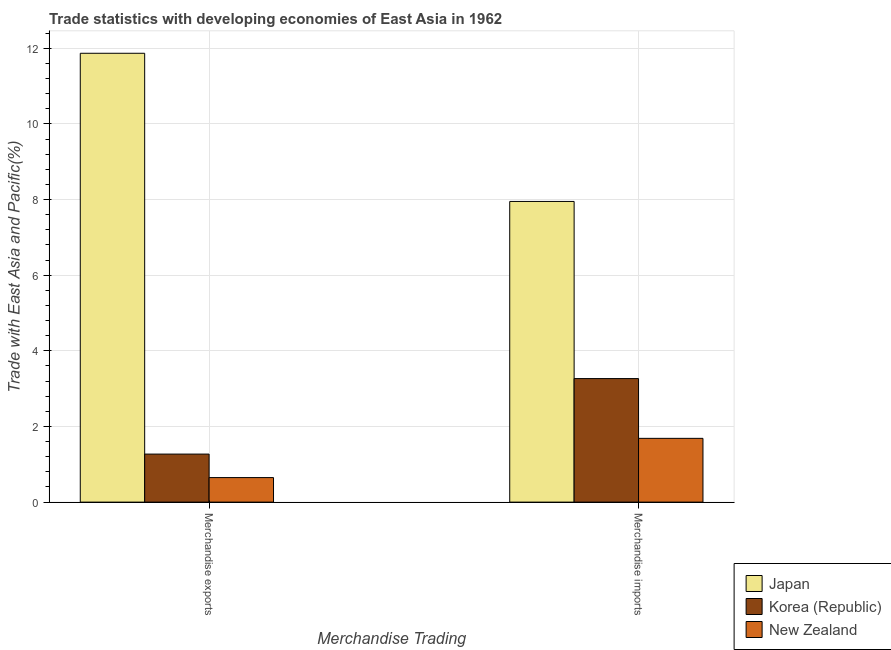How many groups of bars are there?
Provide a succinct answer. 2. Are the number of bars on each tick of the X-axis equal?
Keep it short and to the point. Yes. How many bars are there on the 2nd tick from the left?
Make the answer very short. 3. How many bars are there on the 1st tick from the right?
Give a very brief answer. 3. What is the label of the 2nd group of bars from the left?
Ensure brevity in your answer.  Merchandise imports. What is the merchandise imports in New Zealand?
Make the answer very short. 1.69. Across all countries, what is the maximum merchandise imports?
Your response must be concise. 7.95. Across all countries, what is the minimum merchandise imports?
Give a very brief answer. 1.69. In which country was the merchandise imports maximum?
Provide a succinct answer. Japan. In which country was the merchandise exports minimum?
Offer a terse response. New Zealand. What is the total merchandise exports in the graph?
Give a very brief answer. 13.79. What is the difference between the merchandise exports in Japan and that in New Zealand?
Offer a very short reply. 11.22. What is the difference between the merchandise imports in Korea (Republic) and the merchandise exports in Japan?
Offer a terse response. -8.6. What is the average merchandise imports per country?
Your answer should be very brief. 4.3. What is the difference between the merchandise exports and merchandise imports in Japan?
Your answer should be very brief. 3.92. In how many countries, is the merchandise exports greater than 10 %?
Provide a short and direct response. 1. What is the ratio of the merchandise imports in Korea (Republic) to that in Japan?
Offer a very short reply. 0.41. Is the merchandise imports in New Zealand less than that in Japan?
Keep it short and to the point. Yes. In how many countries, is the merchandise exports greater than the average merchandise exports taken over all countries?
Offer a terse response. 1. Are all the bars in the graph horizontal?
Your response must be concise. No. How many countries are there in the graph?
Keep it short and to the point. 3. Does the graph contain grids?
Give a very brief answer. Yes. How many legend labels are there?
Provide a short and direct response. 3. How are the legend labels stacked?
Provide a succinct answer. Vertical. What is the title of the graph?
Your answer should be compact. Trade statistics with developing economies of East Asia in 1962. Does "Sri Lanka" appear as one of the legend labels in the graph?
Keep it short and to the point. No. What is the label or title of the X-axis?
Offer a very short reply. Merchandise Trading. What is the label or title of the Y-axis?
Keep it short and to the point. Trade with East Asia and Pacific(%). What is the Trade with East Asia and Pacific(%) of Japan in Merchandise exports?
Your response must be concise. 11.87. What is the Trade with East Asia and Pacific(%) of Korea (Republic) in Merchandise exports?
Your answer should be compact. 1.27. What is the Trade with East Asia and Pacific(%) of New Zealand in Merchandise exports?
Your answer should be compact. 0.65. What is the Trade with East Asia and Pacific(%) of Japan in Merchandise imports?
Your response must be concise. 7.95. What is the Trade with East Asia and Pacific(%) in Korea (Republic) in Merchandise imports?
Offer a terse response. 3.27. What is the Trade with East Asia and Pacific(%) in New Zealand in Merchandise imports?
Offer a terse response. 1.69. Across all Merchandise Trading, what is the maximum Trade with East Asia and Pacific(%) of Japan?
Ensure brevity in your answer.  11.87. Across all Merchandise Trading, what is the maximum Trade with East Asia and Pacific(%) in Korea (Republic)?
Your answer should be very brief. 3.27. Across all Merchandise Trading, what is the maximum Trade with East Asia and Pacific(%) of New Zealand?
Give a very brief answer. 1.69. Across all Merchandise Trading, what is the minimum Trade with East Asia and Pacific(%) of Japan?
Offer a very short reply. 7.95. Across all Merchandise Trading, what is the minimum Trade with East Asia and Pacific(%) in Korea (Republic)?
Offer a very short reply. 1.27. Across all Merchandise Trading, what is the minimum Trade with East Asia and Pacific(%) of New Zealand?
Give a very brief answer. 0.65. What is the total Trade with East Asia and Pacific(%) in Japan in the graph?
Keep it short and to the point. 19.82. What is the total Trade with East Asia and Pacific(%) of Korea (Republic) in the graph?
Your response must be concise. 4.54. What is the total Trade with East Asia and Pacific(%) of New Zealand in the graph?
Offer a terse response. 2.34. What is the difference between the Trade with East Asia and Pacific(%) of Japan in Merchandise exports and that in Merchandise imports?
Provide a succinct answer. 3.92. What is the difference between the Trade with East Asia and Pacific(%) in Korea (Republic) in Merchandise exports and that in Merchandise imports?
Provide a succinct answer. -2. What is the difference between the Trade with East Asia and Pacific(%) of New Zealand in Merchandise exports and that in Merchandise imports?
Provide a succinct answer. -1.04. What is the difference between the Trade with East Asia and Pacific(%) of Japan in Merchandise exports and the Trade with East Asia and Pacific(%) of Korea (Republic) in Merchandise imports?
Your response must be concise. 8.6. What is the difference between the Trade with East Asia and Pacific(%) of Japan in Merchandise exports and the Trade with East Asia and Pacific(%) of New Zealand in Merchandise imports?
Keep it short and to the point. 10.18. What is the difference between the Trade with East Asia and Pacific(%) of Korea (Republic) in Merchandise exports and the Trade with East Asia and Pacific(%) of New Zealand in Merchandise imports?
Your response must be concise. -0.42. What is the average Trade with East Asia and Pacific(%) of Japan per Merchandise Trading?
Give a very brief answer. 9.91. What is the average Trade with East Asia and Pacific(%) of Korea (Republic) per Merchandise Trading?
Give a very brief answer. 2.27. What is the average Trade with East Asia and Pacific(%) in New Zealand per Merchandise Trading?
Keep it short and to the point. 1.17. What is the difference between the Trade with East Asia and Pacific(%) in Japan and Trade with East Asia and Pacific(%) in Korea (Republic) in Merchandise exports?
Offer a terse response. 10.6. What is the difference between the Trade with East Asia and Pacific(%) in Japan and Trade with East Asia and Pacific(%) in New Zealand in Merchandise exports?
Give a very brief answer. 11.22. What is the difference between the Trade with East Asia and Pacific(%) of Korea (Republic) and Trade with East Asia and Pacific(%) of New Zealand in Merchandise exports?
Your answer should be compact. 0.62. What is the difference between the Trade with East Asia and Pacific(%) in Japan and Trade with East Asia and Pacific(%) in Korea (Republic) in Merchandise imports?
Offer a terse response. 4.68. What is the difference between the Trade with East Asia and Pacific(%) of Japan and Trade with East Asia and Pacific(%) of New Zealand in Merchandise imports?
Offer a very short reply. 6.26. What is the difference between the Trade with East Asia and Pacific(%) of Korea (Republic) and Trade with East Asia and Pacific(%) of New Zealand in Merchandise imports?
Make the answer very short. 1.58. What is the ratio of the Trade with East Asia and Pacific(%) in Japan in Merchandise exports to that in Merchandise imports?
Provide a succinct answer. 1.49. What is the ratio of the Trade with East Asia and Pacific(%) of Korea (Republic) in Merchandise exports to that in Merchandise imports?
Ensure brevity in your answer.  0.39. What is the ratio of the Trade with East Asia and Pacific(%) in New Zealand in Merchandise exports to that in Merchandise imports?
Your answer should be compact. 0.38. What is the difference between the highest and the second highest Trade with East Asia and Pacific(%) in Japan?
Your response must be concise. 3.92. What is the difference between the highest and the second highest Trade with East Asia and Pacific(%) in Korea (Republic)?
Make the answer very short. 2. What is the difference between the highest and the second highest Trade with East Asia and Pacific(%) of New Zealand?
Offer a very short reply. 1.04. What is the difference between the highest and the lowest Trade with East Asia and Pacific(%) of Japan?
Your answer should be compact. 3.92. What is the difference between the highest and the lowest Trade with East Asia and Pacific(%) of Korea (Republic)?
Keep it short and to the point. 2. What is the difference between the highest and the lowest Trade with East Asia and Pacific(%) of New Zealand?
Offer a terse response. 1.04. 